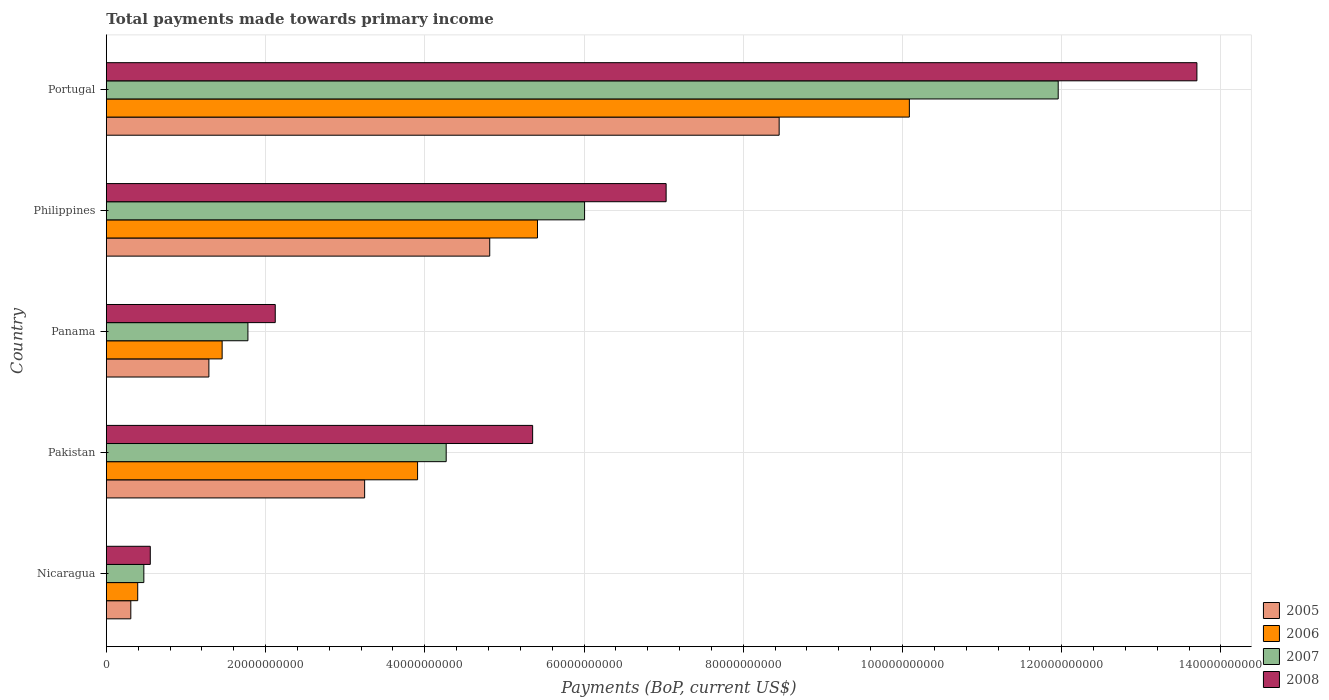Are the number of bars on each tick of the Y-axis equal?
Offer a terse response. Yes. How many bars are there on the 3rd tick from the top?
Your response must be concise. 4. How many bars are there on the 3rd tick from the bottom?
Offer a very short reply. 4. What is the label of the 3rd group of bars from the top?
Provide a succinct answer. Panama. What is the total payments made towards primary income in 2007 in Panama?
Offer a very short reply. 1.78e+1. Across all countries, what is the maximum total payments made towards primary income in 2008?
Your response must be concise. 1.37e+11. Across all countries, what is the minimum total payments made towards primary income in 2005?
Your response must be concise. 3.07e+09. In which country was the total payments made towards primary income in 2008 minimum?
Your response must be concise. Nicaragua. What is the total total payments made towards primary income in 2005 in the graph?
Your answer should be very brief. 1.81e+11. What is the difference between the total payments made towards primary income in 2005 in Pakistan and that in Panama?
Give a very brief answer. 1.96e+1. What is the difference between the total payments made towards primary income in 2008 in Portugal and the total payments made towards primary income in 2006 in Philippines?
Give a very brief answer. 8.28e+1. What is the average total payments made towards primary income in 2006 per country?
Provide a succinct answer. 4.25e+1. What is the difference between the total payments made towards primary income in 2007 and total payments made towards primary income in 2008 in Panama?
Ensure brevity in your answer.  -3.43e+09. What is the ratio of the total payments made towards primary income in 2005 in Panama to that in Portugal?
Offer a terse response. 0.15. What is the difference between the highest and the second highest total payments made towards primary income in 2008?
Keep it short and to the point. 6.67e+1. What is the difference between the highest and the lowest total payments made towards primary income in 2007?
Your answer should be compact. 1.15e+11. In how many countries, is the total payments made towards primary income in 2005 greater than the average total payments made towards primary income in 2005 taken over all countries?
Ensure brevity in your answer.  2. What does the 3rd bar from the top in Pakistan represents?
Ensure brevity in your answer.  2006. Are all the bars in the graph horizontal?
Offer a very short reply. Yes. How many countries are there in the graph?
Make the answer very short. 5. What is the difference between two consecutive major ticks on the X-axis?
Keep it short and to the point. 2.00e+1. Are the values on the major ticks of X-axis written in scientific E-notation?
Your answer should be compact. No. Does the graph contain any zero values?
Provide a succinct answer. No. How many legend labels are there?
Make the answer very short. 4. What is the title of the graph?
Ensure brevity in your answer.  Total payments made towards primary income. What is the label or title of the X-axis?
Give a very brief answer. Payments (BoP, current US$). What is the Payments (BoP, current US$) in 2005 in Nicaragua?
Make the answer very short. 3.07e+09. What is the Payments (BoP, current US$) in 2006 in Nicaragua?
Provide a succinct answer. 3.94e+09. What is the Payments (BoP, current US$) of 2007 in Nicaragua?
Provide a succinct answer. 4.71e+09. What is the Payments (BoP, current US$) in 2008 in Nicaragua?
Offer a very short reply. 5.52e+09. What is the Payments (BoP, current US$) in 2005 in Pakistan?
Give a very brief answer. 3.24e+1. What is the Payments (BoP, current US$) in 2006 in Pakistan?
Offer a very short reply. 3.91e+1. What is the Payments (BoP, current US$) in 2007 in Pakistan?
Ensure brevity in your answer.  4.27e+1. What is the Payments (BoP, current US$) in 2008 in Pakistan?
Make the answer very short. 5.35e+1. What is the Payments (BoP, current US$) of 2005 in Panama?
Your response must be concise. 1.29e+1. What is the Payments (BoP, current US$) of 2006 in Panama?
Keep it short and to the point. 1.45e+1. What is the Payments (BoP, current US$) in 2007 in Panama?
Your answer should be very brief. 1.78e+1. What is the Payments (BoP, current US$) of 2008 in Panama?
Offer a very short reply. 2.12e+1. What is the Payments (BoP, current US$) in 2005 in Philippines?
Your answer should be very brief. 4.82e+1. What is the Payments (BoP, current US$) of 2006 in Philippines?
Your response must be concise. 5.42e+1. What is the Payments (BoP, current US$) in 2007 in Philippines?
Provide a succinct answer. 6.01e+1. What is the Payments (BoP, current US$) in 2008 in Philippines?
Provide a succinct answer. 7.03e+1. What is the Payments (BoP, current US$) in 2005 in Portugal?
Offer a terse response. 8.45e+1. What is the Payments (BoP, current US$) in 2006 in Portugal?
Make the answer very short. 1.01e+11. What is the Payments (BoP, current US$) of 2007 in Portugal?
Ensure brevity in your answer.  1.20e+11. What is the Payments (BoP, current US$) of 2008 in Portugal?
Your answer should be very brief. 1.37e+11. Across all countries, what is the maximum Payments (BoP, current US$) of 2005?
Ensure brevity in your answer.  8.45e+1. Across all countries, what is the maximum Payments (BoP, current US$) of 2006?
Make the answer very short. 1.01e+11. Across all countries, what is the maximum Payments (BoP, current US$) of 2007?
Your response must be concise. 1.20e+11. Across all countries, what is the maximum Payments (BoP, current US$) in 2008?
Offer a terse response. 1.37e+11. Across all countries, what is the minimum Payments (BoP, current US$) of 2005?
Give a very brief answer. 3.07e+09. Across all countries, what is the minimum Payments (BoP, current US$) in 2006?
Make the answer very short. 3.94e+09. Across all countries, what is the minimum Payments (BoP, current US$) in 2007?
Give a very brief answer. 4.71e+09. Across all countries, what is the minimum Payments (BoP, current US$) of 2008?
Give a very brief answer. 5.52e+09. What is the total Payments (BoP, current US$) in 2005 in the graph?
Provide a succinct answer. 1.81e+11. What is the total Payments (BoP, current US$) of 2006 in the graph?
Your answer should be very brief. 2.13e+11. What is the total Payments (BoP, current US$) of 2007 in the graph?
Offer a terse response. 2.45e+11. What is the total Payments (BoP, current US$) of 2008 in the graph?
Your response must be concise. 2.88e+11. What is the difference between the Payments (BoP, current US$) of 2005 in Nicaragua and that in Pakistan?
Keep it short and to the point. -2.94e+1. What is the difference between the Payments (BoP, current US$) in 2006 in Nicaragua and that in Pakistan?
Give a very brief answer. -3.52e+1. What is the difference between the Payments (BoP, current US$) of 2007 in Nicaragua and that in Pakistan?
Offer a terse response. -3.80e+1. What is the difference between the Payments (BoP, current US$) in 2008 in Nicaragua and that in Pakistan?
Keep it short and to the point. -4.80e+1. What is the difference between the Payments (BoP, current US$) in 2005 in Nicaragua and that in Panama?
Your answer should be compact. -9.81e+09. What is the difference between the Payments (BoP, current US$) of 2006 in Nicaragua and that in Panama?
Your answer should be compact. -1.06e+1. What is the difference between the Payments (BoP, current US$) in 2007 in Nicaragua and that in Panama?
Make the answer very short. -1.31e+1. What is the difference between the Payments (BoP, current US$) in 2008 in Nicaragua and that in Panama?
Your answer should be compact. -1.57e+1. What is the difference between the Payments (BoP, current US$) of 2005 in Nicaragua and that in Philippines?
Make the answer very short. -4.51e+1. What is the difference between the Payments (BoP, current US$) of 2006 in Nicaragua and that in Philippines?
Your answer should be compact. -5.02e+1. What is the difference between the Payments (BoP, current US$) of 2007 in Nicaragua and that in Philippines?
Give a very brief answer. -5.54e+1. What is the difference between the Payments (BoP, current US$) of 2008 in Nicaragua and that in Philippines?
Offer a very short reply. -6.48e+1. What is the difference between the Payments (BoP, current US$) in 2005 in Nicaragua and that in Portugal?
Offer a terse response. -8.14e+1. What is the difference between the Payments (BoP, current US$) of 2006 in Nicaragua and that in Portugal?
Provide a short and direct response. -9.69e+1. What is the difference between the Payments (BoP, current US$) of 2007 in Nicaragua and that in Portugal?
Make the answer very short. -1.15e+11. What is the difference between the Payments (BoP, current US$) in 2008 in Nicaragua and that in Portugal?
Your answer should be compact. -1.31e+11. What is the difference between the Payments (BoP, current US$) of 2005 in Pakistan and that in Panama?
Keep it short and to the point. 1.96e+1. What is the difference between the Payments (BoP, current US$) of 2006 in Pakistan and that in Panama?
Provide a short and direct response. 2.45e+1. What is the difference between the Payments (BoP, current US$) in 2007 in Pakistan and that in Panama?
Give a very brief answer. 2.49e+1. What is the difference between the Payments (BoP, current US$) of 2008 in Pakistan and that in Panama?
Ensure brevity in your answer.  3.23e+1. What is the difference between the Payments (BoP, current US$) in 2005 in Pakistan and that in Philippines?
Offer a terse response. -1.57e+1. What is the difference between the Payments (BoP, current US$) in 2006 in Pakistan and that in Philippines?
Give a very brief answer. -1.51e+1. What is the difference between the Payments (BoP, current US$) in 2007 in Pakistan and that in Philippines?
Your answer should be very brief. -1.74e+1. What is the difference between the Payments (BoP, current US$) in 2008 in Pakistan and that in Philippines?
Provide a short and direct response. -1.68e+1. What is the difference between the Payments (BoP, current US$) of 2005 in Pakistan and that in Portugal?
Keep it short and to the point. -5.21e+1. What is the difference between the Payments (BoP, current US$) of 2006 in Pakistan and that in Portugal?
Your answer should be very brief. -6.18e+1. What is the difference between the Payments (BoP, current US$) in 2007 in Pakistan and that in Portugal?
Your answer should be very brief. -7.69e+1. What is the difference between the Payments (BoP, current US$) of 2008 in Pakistan and that in Portugal?
Ensure brevity in your answer.  -8.34e+1. What is the difference between the Payments (BoP, current US$) of 2005 in Panama and that in Philippines?
Your answer should be very brief. -3.53e+1. What is the difference between the Payments (BoP, current US$) of 2006 in Panama and that in Philippines?
Ensure brevity in your answer.  -3.96e+1. What is the difference between the Payments (BoP, current US$) of 2007 in Panama and that in Philippines?
Your answer should be compact. -4.23e+1. What is the difference between the Payments (BoP, current US$) of 2008 in Panama and that in Philippines?
Your answer should be very brief. -4.91e+1. What is the difference between the Payments (BoP, current US$) in 2005 in Panama and that in Portugal?
Provide a short and direct response. -7.16e+1. What is the difference between the Payments (BoP, current US$) of 2006 in Panama and that in Portugal?
Give a very brief answer. -8.63e+1. What is the difference between the Payments (BoP, current US$) of 2007 in Panama and that in Portugal?
Provide a succinct answer. -1.02e+11. What is the difference between the Payments (BoP, current US$) in 2008 in Panama and that in Portugal?
Your answer should be very brief. -1.16e+11. What is the difference between the Payments (BoP, current US$) of 2005 in Philippines and that in Portugal?
Your answer should be very brief. -3.64e+1. What is the difference between the Payments (BoP, current US$) of 2006 in Philippines and that in Portugal?
Keep it short and to the point. -4.67e+1. What is the difference between the Payments (BoP, current US$) of 2007 in Philippines and that in Portugal?
Provide a short and direct response. -5.95e+1. What is the difference between the Payments (BoP, current US$) in 2008 in Philippines and that in Portugal?
Give a very brief answer. -6.67e+1. What is the difference between the Payments (BoP, current US$) of 2005 in Nicaragua and the Payments (BoP, current US$) of 2006 in Pakistan?
Make the answer very short. -3.60e+1. What is the difference between the Payments (BoP, current US$) in 2005 in Nicaragua and the Payments (BoP, current US$) in 2007 in Pakistan?
Your answer should be very brief. -3.96e+1. What is the difference between the Payments (BoP, current US$) of 2005 in Nicaragua and the Payments (BoP, current US$) of 2008 in Pakistan?
Provide a succinct answer. -5.05e+1. What is the difference between the Payments (BoP, current US$) in 2006 in Nicaragua and the Payments (BoP, current US$) in 2007 in Pakistan?
Make the answer very short. -3.87e+1. What is the difference between the Payments (BoP, current US$) of 2006 in Nicaragua and the Payments (BoP, current US$) of 2008 in Pakistan?
Offer a very short reply. -4.96e+1. What is the difference between the Payments (BoP, current US$) of 2007 in Nicaragua and the Payments (BoP, current US$) of 2008 in Pakistan?
Your answer should be compact. -4.88e+1. What is the difference between the Payments (BoP, current US$) of 2005 in Nicaragua and the Payments (BoP, current US$) of 2006 in Panama?
Give a very brief answer. -1.15e+1. What is the difference between the Payments (BoP, current US$) in 2005 in Nicaragua and the Payments (BoP, current US$) in 2007 in Panama?
Ensure brevity in your answer.  -1.47e+1. What is the difference between the Payments (BoP, current US$) in 2005 in Nicaragua and the Payments (BoP, current US$) in 2008 in Panama?
Ensure brevity in your answer.  -1.81e+1. What is the difference between the Payments (BoP, current US$) of 2006 in Nicaragua and the Payments (BoP, current US$) of 2007 in Panama?
Keep it short and to the point. -1.38e+1. What is the difference between the Payments (BoP, current US$) in 2006 in Nicaragua and the Payments (BoP, current US$) in 2008 in Panama?
Provide a succinct answer. -1.73e+1. What is the difference between the Payments (BoP, current US$) of 2007 in Nicaragua and the Payments (BoP, current US$) of 2008 in Panama?
Provide a succinct answer. -1.65e+1. What is the difference between the Payments (BoP, current US$) in 2005 in Nicaragua and the Payments (BoP, current US$) in 2006 in Philippines?
Provide a short and direct response. -5.11e+1. What is the difference between the Payments (BoP, current US$) of 2005 in Nicaragua and the Payments (BoP, current US$) of 2007 in Philippines?
Give a very brief answer. -5.70e+1. What is the difference between the Payments (BoP, current US$) of 2005 in Nicaragua and the Payments (BoP, current US$) of 2008 in Philippines?
Give a very brief answer. -6.72e+1. What is the difference between the Payments (BoP, current US$) in 2006 in Nicaragua and the Payments (BoP, current US$) in 2007 in Philippines?
Your answer should be very brief. -5.61e+1. What is the difference between the Payments (BoP, current US$) of 2006 in Nicaragua and the Payments (BoP, current US$) of 2008 in Philippines?
Give a very brief answer. -6.64e+1. What is the difference between the Payments (BoP, current US$) of 2007 in Nicaragua and the Payments (BoP, current US$) of 2008 in Philippines?
Your answer should be compact. -6.56e+1. What is the difference between the Payments (BoP, current US$) in 2005 in Nicaragua and the Payments (BoP, current US$) in 2006 in Portugal?
Keep it short and to the point. -9.78e+1. What is the difference between the Payments (BoP, current US$) in 2005 in Nicaragua and the Payments (BoP, current US$) in 2007 in Portugal?
Offer a terse response. -1.16e+11. What is the difference between the Payments (BoP, current US$) of 2005 in Nicaragua and the Payments (BoP, current US$) of 2008 in Portugal?
Your response must be concise. -1.34e+11. What is the difference between the Payments (BoP, current US$) of 2006 in Nicaragua and the Payments (BoP, current US$) of 2007 in Portugal?
Keep it short and to the point. -1.16e+11. What is the difference between the Payments (BoP, current US$) in 2006 in Nicaragua and the Payments (BoP, current US$) in 2008 in Portugal?
Make the answer very short. -1.33e+11. What is the difference between the Payments (BoP, current US$) of 2007 in Nicaragua and the Payments (BoP, current US$) of 2008 in Portugal?
Keep it short and to the point. -1.32e+11. What is the difference between the Payments (BoP, current US$) in 2005 in Pakistan and the Payments (BoP, current US$) in 2006 in Panama?
Your answer should be compact. 1.79e+1. What is the difference between the Payments (BoP, current US$) in 2005 in Pakistan and the Payments (BoP, current US$) in 2007 in Panama?
Ensure brevity in your answer.  1.47e+1. What is the difference between the Payments (BoP, current US$) of 2005 in Pakistan and the Payments (BoP, current US$) of 2008 in Panama?
Make the answer very short. 1.12e+1. What is the difference between the Payments (BoP, current US$) of 2006 in Pakistan and the Payments (BoP, current US$) of 2007 in Panama?
Your response must be concise. 2.13e+1. What is the difference between the Payments (BoP, current US$) of 2006 in Pakistan and the Payments (BoP, current US$) of 2008 in Panama?
Provide a succinct answer. 1.79e+1. What is the difference between the Payments (BoP, current US$) in 2007 in Pakistan and the Payments (BoP, current US$) in 2008 in Panama?
Give a very brief answer. 2.15e+1. What is the difference between the Payments (BoP, current US$) of 2005 in Pakistan and the Payments (BoP, current US$) of 2006 in Philippines?
Keep it short and to the point. -2.17e+1. What is the difference between the Payments (BoP, current US$) of 2005 in Pakistan and the Payments (BoP, current US$) of 2007 in Philippines?
Ensure brevity in your answer.  -2.76e+1. What is the difference between the Payments (BoP, current US$) in 2005 in Pakistan and the Payments (BoP, current US$) in 2008 in Philippines?
Your response must be concise. -3.79e+1. What is the difference between the Payments (BoP, current US$) of 2006 in Pakistan and the Payments (BoP, current US$) of 2007 in Philippines?
Offer a terse response. -2.10e+1. What is the difference between the Payments (BoP, current US$) of 2006 in Pakistan and the Payments (BoP, current US$) of 2008 in Philippines?
Your answer should be very brief. -3.12e+1. What is the difference between the Payments (BoP, current US$) of 2007 in Pakistan and the Payments (BoP, current US$) of 2008 in Philippines?
Offer a very short reply. -2.76e+1. What is the difference between the Payments (BoP, current US$) in 2005 in Pakistan and the Payments (BoP, current US$) in 2006 in Portugal?
Make the answer very short. -6.84e+1. What is the difference between the Payments (BoP, current US$) in 2005 in Pakistan and the Payments (BoP, current US$) in 2007 in Portugal?
Offer a very short reply. -8.71e+1. What is the difference between the Payments (BoP, current US$) in 2005 in Pakistan and the Payments (BoP, current US$) in 2008 in Portugal?
Make the answer very short. -1.05e+11. What is the difference between the Payments (BoP, current US$) of 2006 in Pakistan and the Payments (BoP, current US$) of 2007 in Portugal?
Offer a very short reply. -8.05e+1. What is the difference between the Payments (BoP, current US$) of 2006 in Pakistan and the Payments (BoP, current US$) of 2008 in Portugal?
Your response must be concise. -9.79e+1. What is the difference between the Payments (BoP, current US$) of 2007 in Pakistan and the Payments (BoP, current US$) of 2008 in Portugal?
Your answer should be very brief. -9.43e+1. What is the difference between the Payments (BoP, current US$) of 2005 in Panama and the Payments (BoP, current US$) of 2006 in Philippines?
Provide a short and direct response. -4.13e+1. What is the difference between the Payments (BoP, current US$) in 2005 in Panama and the Payments (BoP, current US$) in 2007 in Philippines?
Your answer should be compact. -4.72e+1. What is the difference between the Payments (BoP, current US$) of 2005 in Panama and the Payments (BoP, current US$) of 2008 in Philippines?
Make the answer very short. -5.74e+1. What is the difference between the Payments (BoP, current US$) of 2006 in Panama and the Payments (BoP, current US$) of 2007 in Philippines?
Provide a succinct answer. -4.55e+1. What is the difference between the Payments (BoP, current US$) in 2006 in Panama and the Payments (BoP, current US$) in 2008 in Philippines?
Provide a succinct answer. -5.58e+1. What is the difference between the Payments (BoP, current US$) in 2007 in Panama and the Payments (BoP, current US$) in 2008 in Philippines?
Your answer should be very brief. -5.25e+1. What is the difference between the Payments (BoP, current US$) of 2005 in Panama and the Payments (BoP, current US$) of 2006 in Portugal?
Offer a very short reply. -8.80e+1. What is the difference between the Payments (BoP, current US$) in 2005 in Panama and the Payments (BoP, current US$) in 2007 in Portugal?
Offer a very short reply. -1.07e+11. What is the difference between the Payments (BoP, current US$) of 2005 in Panama and the Payments (BoP, current US$) of 2008 in Portugal?
Provide a short and direct response. -1.24e+11. What is the difference between the Payments (BoP, current US$) of 2006 in Panama and the Payments (BoP, current US$) of 2007 in Portugal?
Give a very brief answer. -1.05e+11. What is the difference between the Payments (BoP, current US$) of 2006 in Panama and the Payments (BoP, current US$) of 2008 in Portugal?
Make the answer very short. -1.22e+11. What is the difference between the Payments (BoP, current US$) in 2007 in Panama and the Payments (BoP, current US$) in 2008 in Portugal?
Offer a terse response. -1.19e+11. What is the difference between the Payments (BoP, current US$) in 2005 in Philippines and the Payments (BoP, current US$) in 2006 in Portugal?
Your answer should be very brief. -5.27e+1. What is the difference between the Payments (BoP, current US$) of 2005 in Philippines and the Payments (BoP, current US$) of 2007 in Portugal?
Keep it short and to the point. -7.14e+1. What is the difference between the Payments (BoP, current US$) of 2005 in Philippines and the Payments (BoP, current US$) of 2008 in Portugal?
Make the answer very short. -8.88e+1. What is the difference between the Payments (BoP, current US$) of 2006 in Philippines and the Payments (BoP, current US$) of 2007 in Portugal?
Provide a short and direct response. -6.54e+1. What is the difference between the Payments (BoP, current US$) of 2006 in Philippines and the Payments (BoP, current US$) of 2008 in Portugal?
Ensure brevity in your answer.  -8.28e+1. What is the difference between the Payments (BoP, current US$) of 2007 in Philippines and the Payments (BoP, current US$) of 2008 in Portugal?
Your response must be concise. -7.69e+1. What is the average Payments (BoP, current US$) of 2005 per country?
Your response must be concise. 3.62e+1. What is the average Payments (BoP, current US$) of 2006 per country?
Your answer should be very brief. 4.25e+1. What is the average Payments (BoP, current US$) in 2007 per country?
Give a very brief answer. 4.90e+1. What is the average Payments (BoP, current US$) in 2008 per country?
Your response must be concise. 5.75e+1. What is the difference between the Payments (BoP, current US$) of 2005 and Payments (BoP, current US$) of 2006 in Nicaragua?
Provide a short and direct response. -8.67e+08. What is the difference between the Payments (BoP, current US$) of 2005 and Payments (BoP, current US$) of 2007 in Nicaragua?
Offer a very short reply. -1.64e+09. What is the difference between the Payments (BoP, current US$) of 2005 and Payments (BoP, current US$) of 2008 in Nicaragua?
Your response must be concise. -2.44e+09. What is the difference between the Payments (BoP, current US$) of 2006 and Payments (BoP, current US$) of 2007 in Nicaragua?
Your response must be concise. -7.70e+08. What is the difference between the Payments (BoP, current US$) of 2006 and Payments (BoP, current US$) of 2008 in Nicaragua?
Make the answer very short. -1.58e+09. What is the difference between the Payments (BoP, current US$) of 2007 and Payments (BoP, current US$) of 2008 in Nicaragua?
Provide a succinct answer. -8.07e+08. What is the difference between the Payments (BoP, current US$) of 2005 and Payments (BoP, current US$) of 2006 in Pakistan?
Provide a short and direct response. -6.65e+09. What is the difference between the Payments (BoP, current US$) of 2005 and Payments (BoP, current US$) of 2007 in Pakistan?
Offer a very short reply. -1.02e+1. What is the difference between the Payments (BoP, current US$) of 2005 and Payments (BoP, current US$) of 2008 in Pakistan?
Ensure brevity in your answer.  -2.11e+1. What is the difference between the Payments (BoP, current US$) of 2006 and Payments (BoP, current US$) of 2007 in Pakistan?
Provide a short and direct response. -3.59e+09. What is the difference between the Payments (BoP, current US$) of 2006 and Payments (BoP, current US$) of 2008 in Pakistan?
Your answer should be very brief. -1.45e+1. What is the difference between the Payments (BoP, current US$) in 2007 and Payments (BoP, current US$) in 2008 in Pakistan?
Make the answer very short. -1.09e+1. What is the difference between the Payments (BoP, current US$) of 2005 and Payments (BoP, current US$) of 2006 in Panama?
Make the answer very short. -1.66e+09. What is the difference between the Payments (BoP, current US$) of 2005 and Payments (BoP, current US$) of 2007 in Panama?
Offer a very short reply. -4.90e+09. What is the difference between the Payments (BoP, current US$) in 2005 and Payments (BoP, current US$) in 2008 in Panama?
Your answer should be very brief. -8.33e+09. What is the difference between the Payments (BoP, current US$) of 2006 and Payments (BoP, current US$) of 2007 in Panama?
Provide a succinct answer. -3.24e+09. What is the difference between the Payments (BoP, current US$) in 2006 and Payments (BoP, current US$) in 2008 in Panama?
Provide a short and direct response. -6.67e+09. What is the difference between the Payments (BoP, current US$) of 2007 and Payments (BoP, current US$) of 2008 in Panama?
Make the answer very short. -3.43e+09. What is the difference between the Payments (BoP, current US$) of 2005 and Payments (BoP, current US$) of 2006 in Philippines?
Ensure brevity in your answer.  -6.00e+09. What is the difference between the Payments (BoP, current US$) of 2005 and Payments (BoP, current US$) of 2007 in Philippines?
Offer a terse response. -1.19e+1. What is the difference between the Payments (BoP, current US$) of 2005 and Payments (BoP, current US$) of 2008 in Philippines?
Provide a short and direct response. -2.22e+1. What is the difference between the Payments (BoP, current US$) in 2006 and Payments (BoP, current US$) in 2007 in Philippines?
Provide a short and direct response. -5.92e+09. What is the difference between the Payments (BoP, current US$) in 2006 and Payments (BoP, current US$) in 2008 in Philippines?
Give a very brief answer. -1.62e+1. What is the difference between the Payments (BoP, current US$) of 2007 and Payments (BoP, current US$) of 2008 in Philippines?
Offer a terse response. -1.02e+1. What is the difference between the Payments (BoP, current US$) of 2005 and Payments (BoP, current US$) of 2006 in Portugal?
Make the answer very short. -1.64e+1. What is the difference between the Payments (BoP, current US$) in 2005 and Payments (BoP, current US$) in 2007 in Portugal?
Provide a short and direct response. -3.50e+1. What is the difference between the Payments (BoP, current US$) in 2005 and Payments (BoP, current US$) in 2008 in Portugal?
Provide a succinct answer. -5.25e+1. What is the difference between the Payments (BoP, current US$) of 2006 and Payments (BoP, current US$) of 2007 in Portugal?
Your answer should be very brief. -1.87e+1. What is the difference between the Payments (BoP, current US$) of 2006 and Payments (BoP, current US$) of 2008 in Portugal?
Ensure brevity in your answer.  -3.61e+1. What is the difference between the Payments (BoP, current US$) of 2007 and Payments (BoP, current US$) of 2008 in Portugal?
Give a very brief answer. -1.74e+1. What is the ratio of the Payments (BoP, current US$) in 2005 in Nicaragua to that in Pakistan?
Keep it short and to the point. 0.09. What is the ratio of the Payments (BoP, current US$) in 2006 in Nicaragua to that in Pakistan?
Offer a very short reply. 0.1. What is the ratio of the Payments (BoP, current US$) of 2007 in Nicaragua to that in Pakistan?
Provide a succinct answer. 0.11. What is the ratio of the Payments (BoP, current US$) of 2008 in Nicaragua to that in Pakistan?
Your answer should be compact. 0.1. What is the ratio of the Payments (BoP, current US$) of 2005 in Nicaragua to that in Panama?
Keep it short and to the point. 0.24. What is the ratio of the Payments (BoP, current US$) of 2006 in Nicaragua to that in Panama?
Make the answer very short. 0.27. What is the ratio of the Payments (BoP, current US$) of 2007 in Nicaragua to that in Panama?
Your response must be concise. 0.27. What is the ratio of the Payments (BoP, current US$) in 2008 in Nicaragua to that in Panama?
Ensure brevity in your answer.  0.26. What is the ratio of the Payments (BoP, current US$) in 2005 in Nicaragua to that in Philippines?
Your answer should be compact. 0.06. What is the ratio of the Payments (BoP, current US$) in 2006 in Nicaragua to that in Philippines?
Your response must be concise. 0.07. What is the ratio of the Payments (BoP, current US$) in 2007 in Nicaragua to that in Philippines?
Make the answer very short. 0.08. What is the ratio of the Payments (BoP, current US$) in 2008 in Nicaragua to that in Philippines?
Make the answer very short. 0.08. What is the ratio of the Payments (BoP, current US$) in 2005 in Nicaragua to that in Portugal?
Ensure brevity in your answer.  0.04. What is the ratio of the Payments (BoP, current US$) of 2006 in Nicaragua to that in Portugal?
Give a very brief answer. 0.04. What is the ratio of the Payments (BoP, current US$) in 2007 in Nicaragua to that in Portugal?
Offer a terse response. 0.04. What is the ratio of the Payments (BoP, current US$) in 2008 in Nicaragua to that in Portugal?
Keep it short and to the point. 0.04. What is the ratio of the Payments (BoP, current US$) of 2005 in Pakistan to that in Panama?
Offer a terse response. 2.52. What is the ratio of the Payments (BoP, current US$) in 2006 in Pakistan to that in Panama?
Give a very brief answer. 2.69. What is the ratio of the Payments (BoP, current US$) of 2007 in Pakistan to that in Panama?
Provide a succinct answer. 2.4. What is the ratio of the Payments (BoP, current US$) in 2008 in Pakistan to that in Panama?
Your response must be concise. 2.52. What is the ratio of the Payments (BoP, current US$) of 2005 in Pakistan to that in Philippines?
Make the answer very short. 0.67. What is the ratio of the Payments (BoP, current US$) in 2006 in Pakistan to that in Philippines?
Keep it short and to the point. 0.72. What is the ratio of the Payments (BoP, current US$) of 2007 in Pakistan to that in Philippines?
Make the answer very short. 0.71. What is the ratio of the Payments (BoP, current US$) of 2008 in Pakistan to that in Philippines?
Provide a short and direct response. 0.76. What is the ratio of the Payments (BoP, current US$) in 2005 in Pakistan to that in Portugal?
Provide a succinct answer. 0.38. What is the ratio of the Payments (BoP, current US$) in 2006 in Pakistan to that in Portugal?
Make the answer very short. 0.39. What is the ratio of the Payments (BoP, current US$) of 2007 in Pakistan to that in Portugal?
Keep it short and to the point. 0.36. What is the ratio of the Payments (BoP, current US$) of 2008 in Pakistan to that in Portugal?
Ensure brevity in your answer.  0.39. What is the ratio of the Payments (BoP, current US$) in 2005 in Panama to that in Philippines?
Offer a very short reply. 0.27. What is the ratio of the Payments (BoP, current US$) of 2006 in Panama to that in Philippines?
Provide a short and direct response. 0.27. What is the ratio of the Payments (BoP, current US$) in 2007 in Panama to that in Philippines?
Make the answer very short. 0.3. What is the ratio of the Payments (BoP, current US$) in 2008 in Panama to that in Philippines?
Provide a short and direct response. 0.3. What is the ratio of the Payments (BoP, current US$) in 2005 in Panama to that in Portugal?
Offer a very short reply. 0.15. What is the ratio of the Payments (BoP, current US$) of 2006 in Panama to that in Portugal?
Ensure brevity in your answer.  0.14. What is the ratio of the Payments (BoP, current US$) of 2007 in Panama to that in Portugal?
Provide a succinct answer. 0.15. What is the ratio of the Payments (BoP, current US$) in 2008 in Panama to that in Portugal?
Ensure brevity in your answer.  0.15. What is the ratio of the Payments (BoP, current US$) of 2005 in Philippines to that in Portugal?
Provide a short and direct response. 0.57. What is the ratio of the Payments (BoP, current US$) in 2006 in Philippines to that in Portugal?
Your answer should be very brief. 0.54. What is the ratio of the Payments (BoP, current US$) of 2007 in Philippines to that in Portugal?
Offer a terse response. 0.5. What is the ratio of the Payments (BoP, current US$) of 2008 in Philippines to that in Portugal?
Ensure brevity in your answer.  0.51. What is the difference between the highest and the second highest Payments (BoP, current US$) in 2005?
Keep it short and to the point. 3.64e+1. What is the difference between the highest and the second highest Payments (BoP, current US$) of 2006?
Offer a very short reply. 4.67e+1. What is the difference between the highest and the second highest Payments (BoP, current US$) in 2007?
Ensure brevity in your answer.  5.95e+1. What is the difference between the highest and the second highest Payments (BoP, current US$) in 2008?
Keep it short and to the point. 6.67e+1. What is the difference between the highest and the lowest Payments (BoP, current US$) in 2005?
Offer a very short reply. 8.14e+1. What is the difference between the highest and the lowest Payments (BoP, current US$) in 2006?
Offer a terse response. 9.69e+1. What is the difference between the highest and the lowest Payments (BoP, current US$) of 2007?
Provide a short and direct response. 1.15e+11. What is the difference between the highest and the lowest Payments (BoP, current US$) in 2008?
Provide a short and direct response. 1.31e+11. 